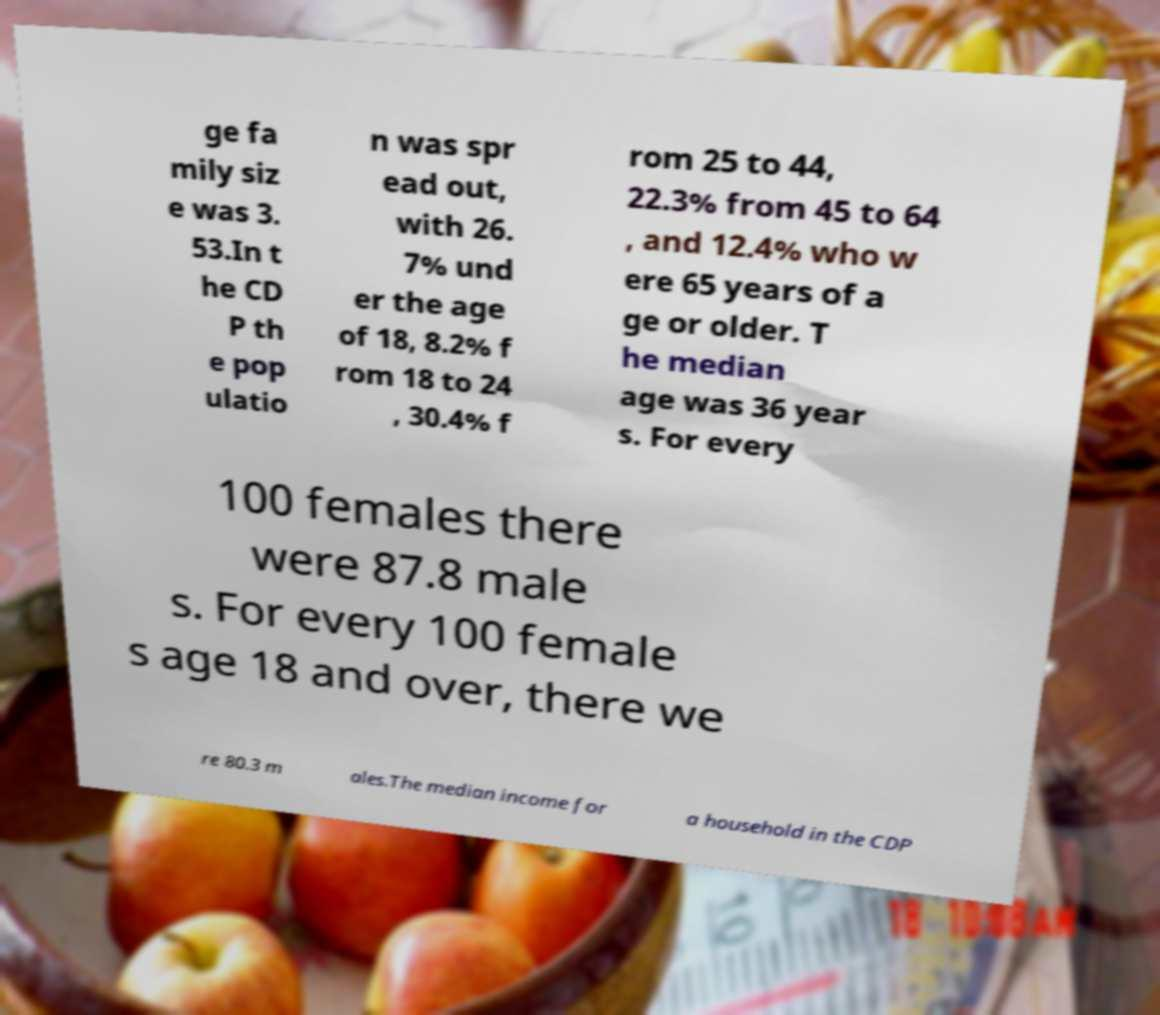Can you accurately transcribe the text from the provided image for me? ge fa mily siz e was 3. 53.In t he CD P th e pop ulatio n was spr ead out, with 26. 7% und er the age of 18, 8.2% f rom 18 to 24 , 30.4% f rom 25 to 44, 22.3% from 45 to 64 , and 12.4% who w ere 65 years of a ge or older. T he median age was 36 year s. For every 100 females there were 87.8 male s. For every 100 female s age 18 and over, there we re 80.3 m ales.The median income for a household in the CDP 